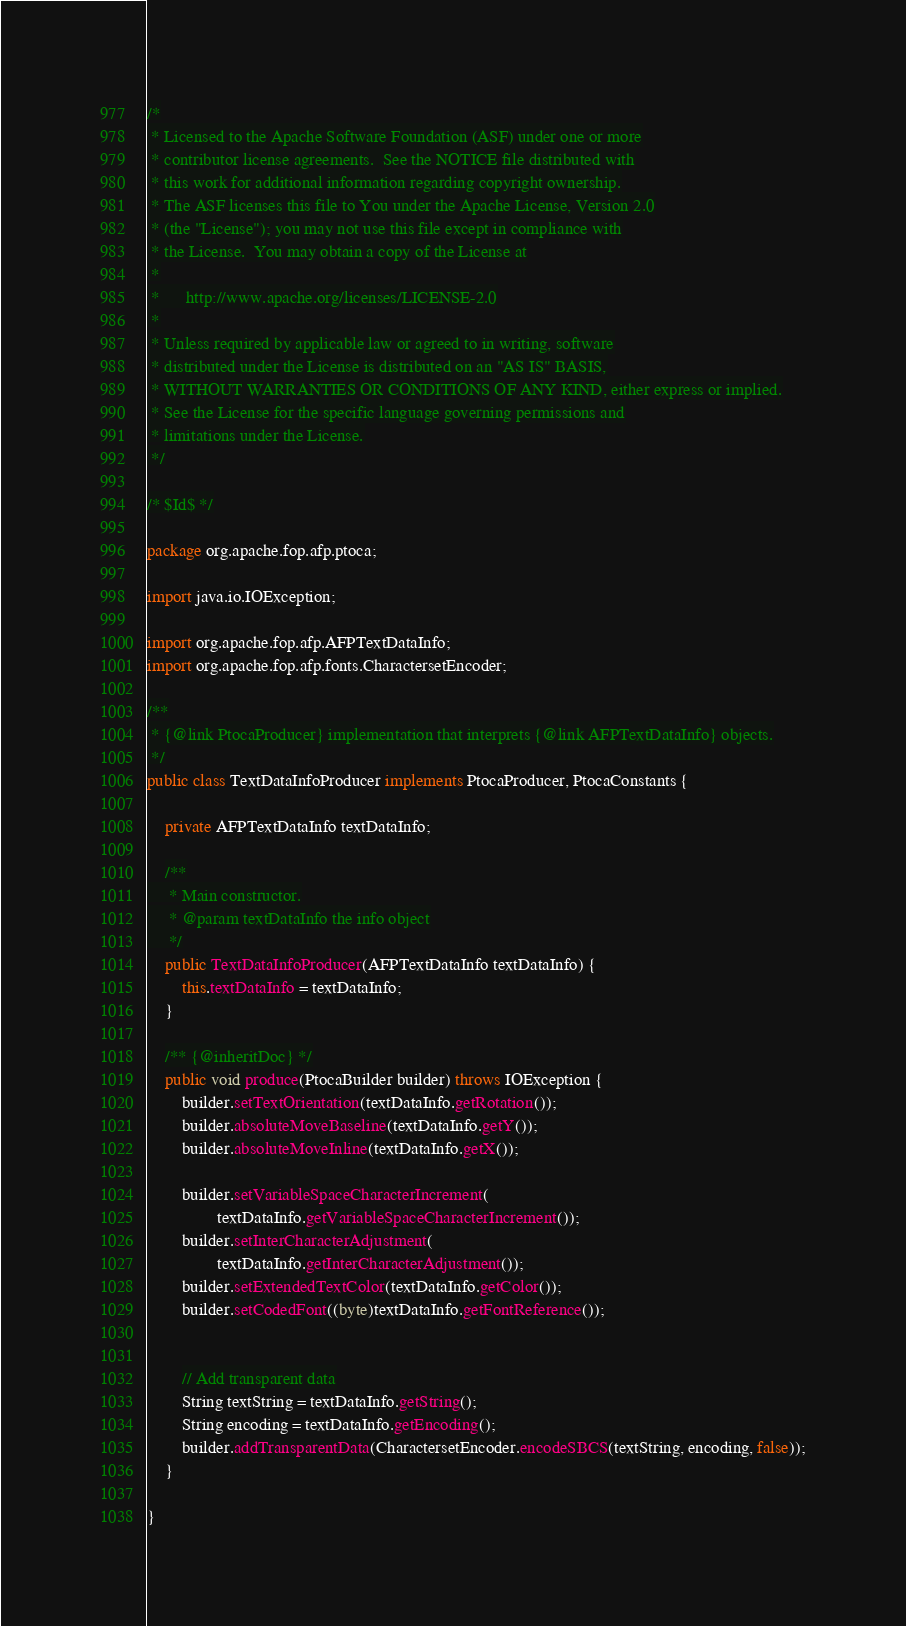Convert code to text. <code><loc_0><loc_0><loc_500><loc_500><_Java_>/*
 * Licensed to the Apache Software Foundation (ASF) under one or more
 * contributor license agreements.  See the NOTICE file distributed with
 * this work for additional information regarding copyright ownership.
 * The ASF licenses this file to You under the Apache License, Version 2.0
 * (the "License"); you may not use this file except in compliance with
 * the License.  You may obtain a copy of the License at
 *
 *      http://www.apache.org/licenses/LICENSE-2.0
 *
 * Unless required by applicable law or agreed to in writing, software
 * distributed under the License is distributed on an "AS IS" BASIS,
 * WITHOUT WARRANTIES OR CONDITIONS OF ANY KIND, either express or implied.
 * See the License for the specific language governing permissions and
 * limitations under the License.
 */

/* $Id$ */

package org.apache.fop.afp.ptoca;

import java.io.IOException;

import org.apache.fop.afp.AFPTextDataInfo;
import org.apache.fop.afp.fonts.CharactersetEncoder;

/**
 * {@link PtocaProducer} implementation that interprets {@link AFPTextDataInfo} objects.
 */
public class TextDataInfoProducer implements PtocaProducer, PtocaConstants {

    private AFPTextDataInfo textDataInfo;

    /**
     * Main constructor.
     * @param textDataInfo the info object
     */
    public TextDataInfoProducer(AFPTextDataInfo textDataInfo) {
        this.textDataInfo = textDataInfo;
    }

    /** {@inheritDoc} */
    public void produce(PtocaBuilder builder) throws IOException {
        builder.setTextOrientation(textDataInfo.getRotation());
        builder.absoluteMoveBaseline(textDataInfo.getY());
        builder.absoluteMoveInline(textDataInfo.getX());

        builder.setVariableSpaceCharacterIncrement(
                textDataInfo.getVariableSpaceCharacterIncrement());
        builder.setInterCharacterAdjustment(
                textDataInfo.getInterCharacterAdjustment());
        builder.setExtendedTextColor(textDataInfo.getColor());
        builder.setCodedFont((byte)textDataInfo.getFontReference());


        // Add transparent data
        String textString = textDataInfo.getString();
        String encoding = textDataInfo.getEncoding();
        builder.addTransparentData(CharactersetEncoder.encodeSBCS(textString, encoding, false));
    }

}
</code> 